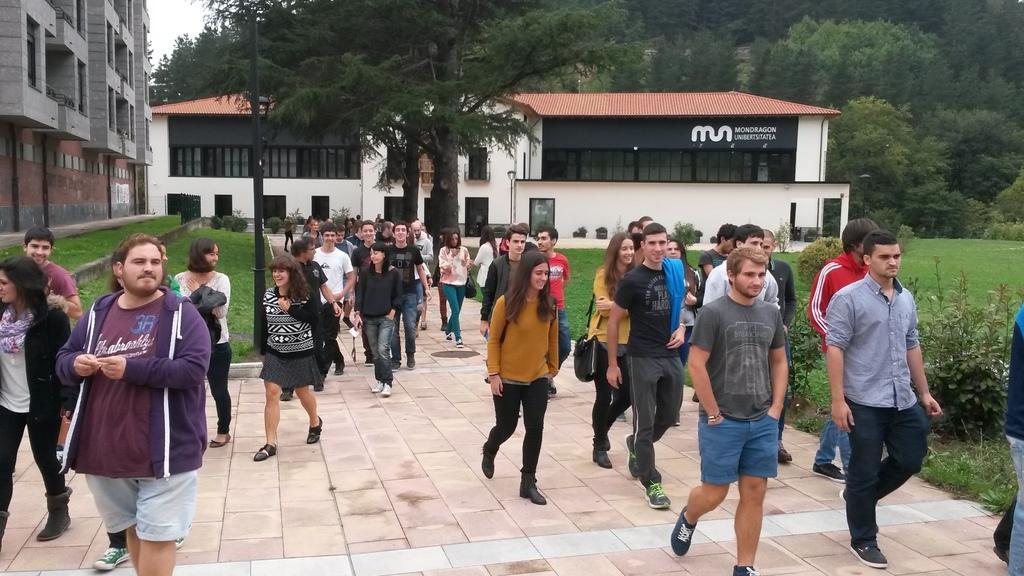Can you describe this image briefly? In the center of the image a group of people are present. In the background of the image we can see a trees, buildings are there. At the bottom of the image ground is present. On the right side of the image some plants and grass are there. At the top left corner sky is present. In the middle of the image a pole is there. 